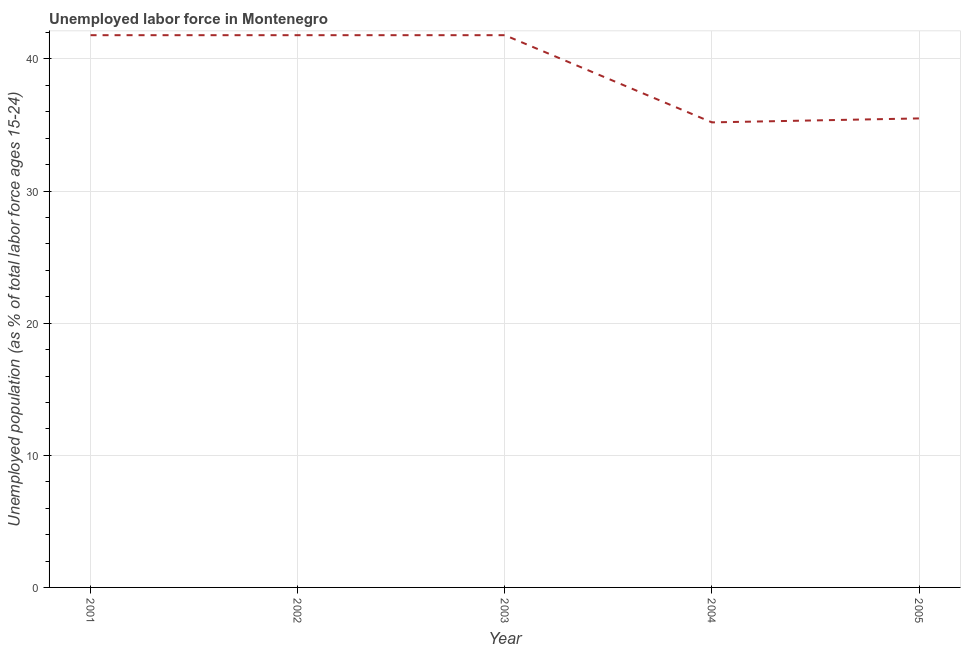What is the total unemployed youth population in 2001?
Provide a short and direct response. 41.8. Across all years, what is the maximum total unemployed youth population?
Your answer should be compact. 41.8. Across all years, what is the minimum total unemployed youth population?
Ensure brevity in your answer.  35.2. In which year was the total unemployed youth population maximum?
Provide a succinct answer. 2001. In which year was the total unemployed youth population minimum?
Keep it short and to the point. 2004. What is the sum of the total unemployed youth population?
Make the answer very short. 196.1. What is the difference between the total unemployed youth population in 2004 and 2005?
Your answer should be very brief. -0.3. What is the average total unemployed youth population per year?
Offer a very short reply. 39.22. What is the median total unemployed youth population?
Keep it short and to the point. 41.8. In how many years, is the total unemployed youth population greater than 16 %?
Your answer should be very brief. 5. What is the ratio of the total unemployed youth population in 2003 to that in 2005?
Provide a succinct answer. 1.18. Is the total unemployed youth population in 2003 less than that in 2005?
Your answer should be compact. No. Is the difference between the total unemployed youth population in 2002 and 2003 greater than the difference between any two years?
Your response must be concise. No. What is the difference between the highest and the lowest total unemployed youth population?
Your answer should be compact. 6.6. In how many years, is the total unemployed youth population greater than the average total unemployed youth population taken over all years?
Give a very brief answer. 3. How many lines are there?
Provide a short and direct response. 1. How many years are there in the graph?
Provide a succinct answer. 5. What is the difference between two consecutive major ticks on the Y-axis?
Your answer should be compact. 10. Does the graph contain grids?
Your response must be concise. Yes. What is the title of the graph?
Provide a short and direct response. Unemployed labor force in Montenegro. What is the label or title of the Y-axis?
Your answer should be compact. Unemployed population (as % of total labor force ages 15-24). What is the Unemployed population (as % of total labor force ages 15-24) in 2001?
Keep it short and to the point. 41.8. What is the Unemployed population (as % of total labor force ages 15-24) in 2002?
Ensure brevity in your answer.  41.8. What is the Unemployed population (as % of total labor force ages 15-24) of 2003?
Keep it short and to the point. 41.8. What is the Unemployed population (as % of total labor force ages 15-24) in 2004?
Provide a succinct answer. 35.2. What is the Unemployed population (as % of total labor force ages 15-24) in 2005?
Offer a very short reply. 35.5. What is the difference between the Unemployed population (as % of total labor force ages 15-24) in 2001 and 2002?
Offer a very short reply. 0. What is the difference between the Unemployed population (as % of total labor force ages 15-24) in 2001 and 2003?
Make the answer very short. 0. What is the difference between the Unemployed population (as % of total labor force ages 15-24) in 2001 and 2004?
Your answer should be very brief. 6.6. What is the difference between the Unemployed population (as % of total labor force ages 15-24) in 2001 and 2005?
Keep it short and to the point. 6.3. What is the difference between the Unemployed population (as % of total labor force ages 15-24) in 2004 and 2005?
Ensure brevity in your answer.  -0.3. What is the ratio of the Unemployed population (as % of total labor force ages 15-24) in 2001 to that in 2002?
Give a very brief answer. 1. What is the ratio of the Unemployed population (as % of total labor force ages 15-24) in 2001 to that in 2003?
Ensure brevity in your answer.  1. What is the ratio of the Unemployed population (as % of total labor force ages 15-24) in 2001 to that in 2004?
Provide a short and direct response. 1.19. What is the ratio of the Unemployed population (as % of total labor force ages 15-24) in 2001 to that in 2005?
Keep it short and to the point. 1.18. What is the ratio of the Unemployed population (as % of total labor force ages 15-24) in 2002 to that in 2004?
Make the answer very short. 1.19. What is the ratio of the Unemployed population (as % of total labor force ages 15-24) in 2002 to that in 2005?
Ensure brevity in your answer.  1.18. What is the ratio of the Unemployed population (as % of total labor force ages 15-24) in 2003 to that in 2004?
Keep it short and to the point. 1.19. What is the ratio of the Unemployed population (as % of total labor force ages 15-24) in 2003 to that in 2005?
Your answer should be very brief. 1.18. What is the ratio of the Unemployed population (as % of total labor force ages 15-24) in 2004 to that in 2005?
Make the answer very short. 0.99. 